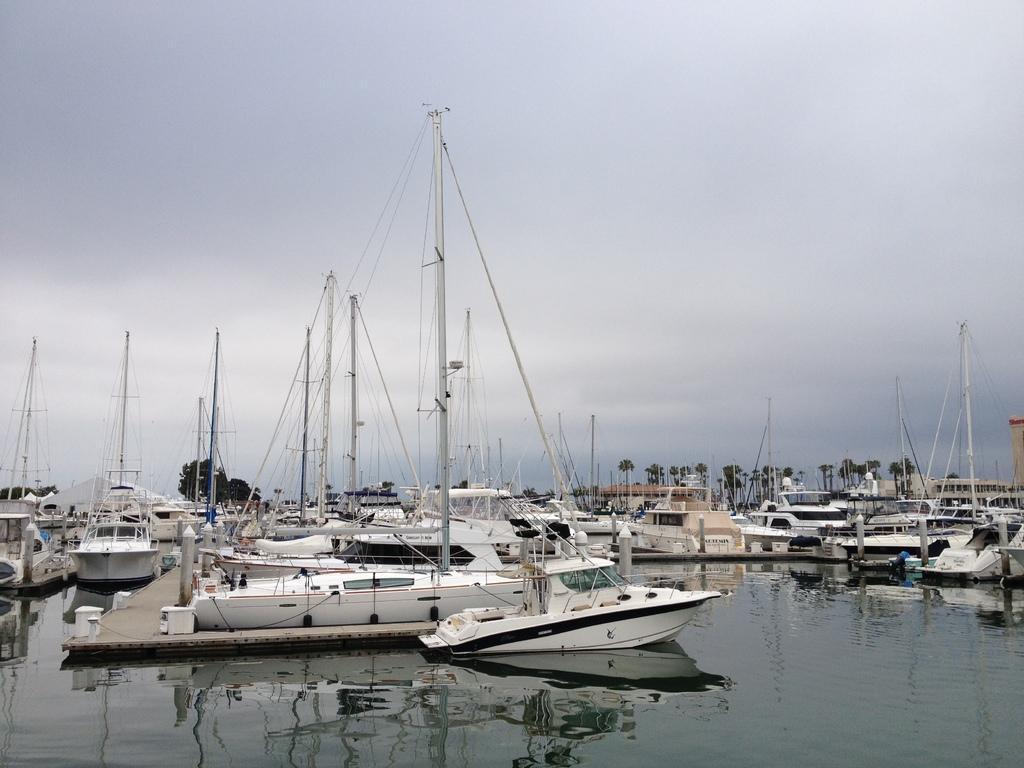In one or two sentences, can you explain what this image depicts? At the bottom of the image there is water. On the water there are many boats with poles and ropes. Also there is a path with wooden deck. In the background there are trees. At the top of the image there is a sky with clouds. 